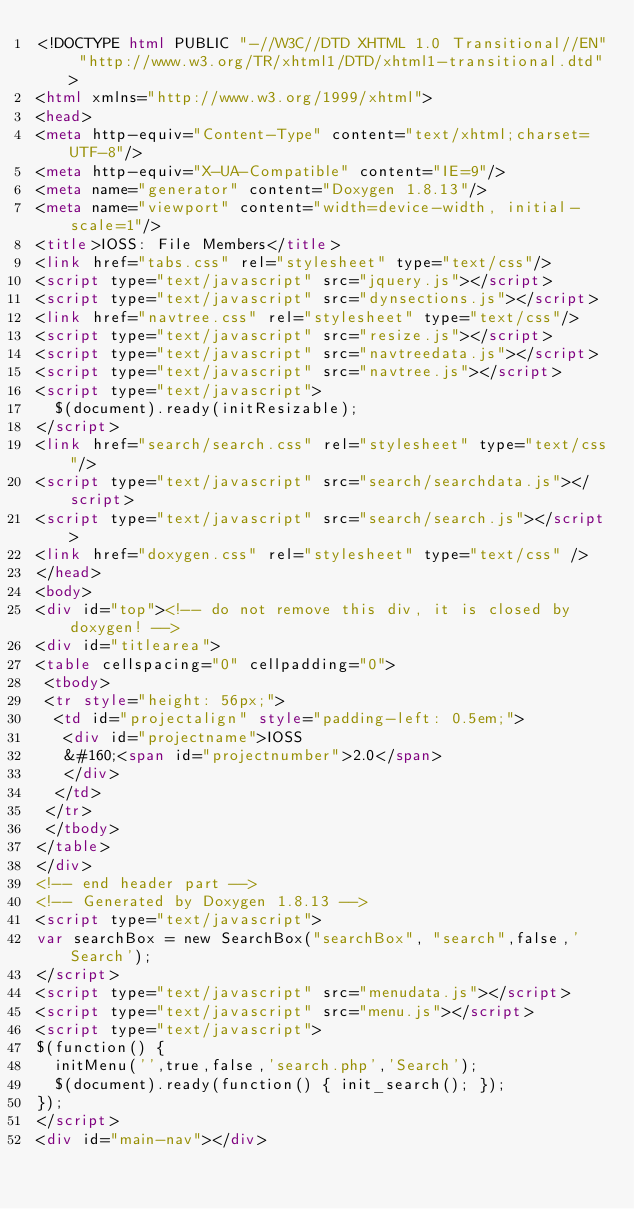<code> <loc_0><loc_0><loc_500><loc_500><_HTML_><!DOCTYPE html PUBLIC "-//W3C//DTD XHTML 1.0 Transitional//EN" "http://www.w3.org/TR/xhtml1/DTD/xhtml1-transitional.dtd">
<html xmlns="http://www.w3.org/1999/xhtml">
<head>
<meta http-equiv="Content-Type" content="text/xhtml;charset=UTF-8"/>
<meta http-equiv="X-UA-Compatible" content="IE=9"/>
<meta name="generator" content="Doxygen 1.8.13"/>
<meta name="viewport" content="width=device-width, initial-scale=1"/>
<title>IOSS: File Members</title>
<link href="tabs.css" rel="stylesheet" type="text/css"/>
<script type="text/javascript" src="jquery.js"></script>
<script type="text/javascript" src="dynsections.js"></script>
<link href="navtree.css" rel="stylesheet" type="text/css"/>
<script type="text/javascript" src="resize.js"></script>
<script type="text/javascript" src="navtreedata.js"></script>
<script type="text/javascript" src="navtree.js"></script>
<script type="text/javascript">
  $(document).ready(initResizable);
</script>
<link href="search/search.css" rel="stylesheet" type="text/css"/>
<script type="text/javascript" src="search/searchdata.js"></script>
<script type="text/javascript" src="search/search.js"></script>
<link href="doxygen.css" rel="stylesheet" type="text/css" />
</head>
<body>
<div id="top"><!-- do not remove this div, it is closed by doxygen! -->
<div id="titlearea">
<table cellspacing="0" cellpadding="0">
 <tbody>
 <tr style="height: 56px;">
  <td id="projectalign" style="padding-left: 0.5em;">
   <div id="projectname">IOSS
   &#160;<span id="projectnumber">2.0</span>
   </div>
  </td>
 </tr>
 </tbody>
</table>
</div>
<!-- end header part -->
<!-- Generated by Doxygen 1.8.13 -->
<script type="text/javascript">
var searchBox = new SearchBox("searchBox", "search",false,'Search');
</script>
<script type="text/javascript" src="menudata.js"></script>
<script type="text/javascript" src="menu.js"></script>
<script type="text/javascript">
$(function() {
  initMenu('',true,false,'search.php','Search');
  $(document).ready(function() { init_search(); });
});
</script>
<div id="main-nav"></div></code> 